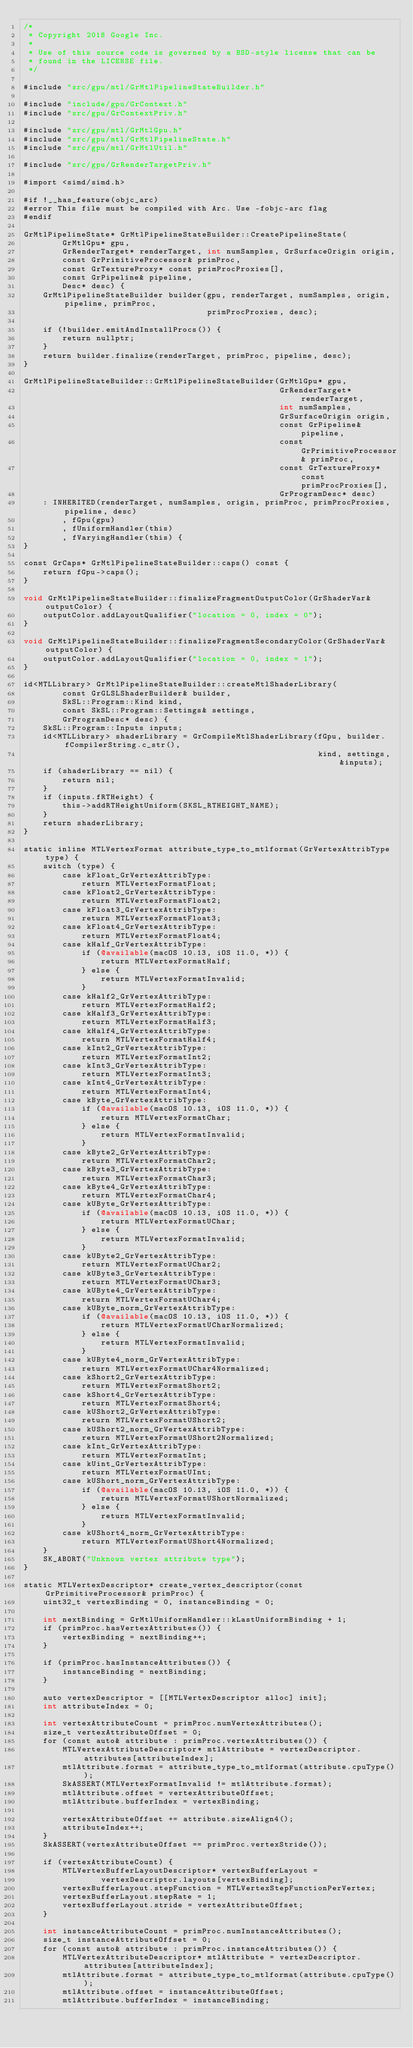Convert code to text. <code><loc_0><loc_0><loc_500><loc_500><_ObjectiveC_>/*
 * Copyright 2018 Google Inc.
 *
 * Use of this source code is governed by a BSD-style license that can be
 * found in the LICENSE file.
 */

#include "src/gpu/mtl/GrMtlPipelineStateBuilder.h"

#include "include/gpu/GrContext.h"
#include "src/gpu/GrContextPriv.h"

#include "src/gpu/mtl/GrMtlGpu.h"
#include "src/gpu/mtl/GrMtlPipelineState.h"
#include "src/gpu/mtl/GrMtlUtil.h"

#include "src/gpu/GrRenderTargetPriv.h"

#import <simd/simd.h>

#if !__has_feature(objc_arc)
#error This file must be compiled with Arc. Use -fobjc-arc flag
#endif

GrMtlPipelineState* GrMtlPipelineStateBuilder::CreatePipelineState(
        GrMtlGpu* gpu,
        GrRenderTarget* renderTarget, int numSamples, GrSurfaceOrigin origin,
        const GrPrimitiveProcessor& primProc,
        const GrTextureProxy* const primProcProxies[],
        const GrPipeline& pipeline,
        Desc* desc) {
    GrMtlPipelineStateBuilder builder(gpu, renderTarget, numSamples, origin, pipeline, primProc,
                                      primProcProxies, desc);

    if (!builder.emitAndInstallProcs()) {
        return nullptr;
    }
    return builder.finalize(renderTarget, primProc, pipeline, desc);
}

GrMtlPipelineStateBuilder::GrMtlPipelineStateBuilder(GrMtlGpu* gpu,
                                                     GrRenderTarget* renderTarget,
                                                     int numSamples,
                                                     GrSurfaceOrigin origin,
                                                     const GrPipeline& pipeline,
                                                     const GrPrimitiveProcessor& primProc,
                                                     const GrTextureProxy* const primProcProxies[],
                                                     GrProgramDesc* desc)
    : INHERITED(renderTarget, numSamples, origin, primProc, primProcProxies, pipeline, desc)
        , fGpu(gpu)
        , fUniformHandler(this)
        , fVaryingHandler(this) {
}

const GrCaps* GrMtlPipelineStateBuilder::caps() const {
    return fGpu->caps();
}

void GrMtlPipelineStateBuilder::finalizeFragmentOutputColor(GrShaderVar& outputColor) {
    outputColor.addLayoutQualifier("location = 0, index = 0");
}

void GrMtlPipelineStateBuilder::finalizeFragmentSecondaryColor(GrShaderVar& outputColor) {
    outputColor.addLayoutQualifier("location = 0, index = 1");
}

id<MTLLibrary> GrMtlPipelineStateBuilder::createMtlShaderLibrary(
        const GrGLSLShaderBuilder& builder,
        SkSL::Program::Kind kind,
        const SkSL::Program::Settings& settings,
        GrProgramDesc* desc) {
    SkSL::Program::Inputs inputs;
    id<MTLLibrary> shaderLibrary = GrCompileMtlShaderLibrary(fGpu, builder.fCompilerString.c_str(),
                                                             kind, settings, &inputs);
    if (shaderLibrary == nil) {
        return nil;
    }
    if (inputs.fRTHeight) {
        this->addRTHeightUniform(SKSL_RTHEIGHT_NAME);
    }
    return shaderLibrary;
}

static inline MTLVertexFormat attribute_type_to_mtlformat(GrVertexAttribType type) {
    switch (type) {
        case kFloat_GrVertexAttribType:
            return MTLVertexFormatFloat;
        case kFloat2_GrVertexAttribType:
            return MTLVertexFormatFloat2;
        case kFloat3_GrVertexAttribType:
            return MTLVertexFormatFloat3;
        case kFloat4_GrVertexAttribType:
            return MTLVertexFormatFloat4;
        case kHalf_GrVertexAttribType:
            if (@available(macOS 10.13, iOS 11.0, *)) {
                return MTLVertexFormatHalf;
            } else {
                return MTLVertexFormatInvalid;
            }
        case kHalf2_GrVertexAttribType:
            return MTLVertexFormatHalf2;
        case kHalf3_GrVertexAttribType:
            return MTLVertexFormatHalf3;
        case kHalf4_GrVertexAttribType:
            return MTLVertexFormatHalf4;
        case kInt2_GrVertexAttribType:
            return MTLVertexFormatInt2;
        case kInt3_GrVertexAttribType:
            return MTLVertexFormatInt3;
        case kInt4_GrVertexAttribType:
            return MTLVertexFormatInt4;
        case kByte_GrVertexAttribType:
            if (@available(macOS 10.13, iOS 11.0, *)) {
                return MTLVertexFormatChar;
            } else {
                return MTLVertexFormatInvalid;
            }
        case kByte2_GrVertexAttribType:
            return MTLVertexFormatChar2;
        case kByte3_GrVertexAttribType:
            return MTLVertexFormatChar3;
        case kByte4_GrVertexAttribType:
            return MTLVertexFormatChar4;
        case kUByte_GrVertexAttribType:
            if (@available(macOS 10.13, iOS 11.0, *)) {
                return MTLVertexFormatUChar;
            } else {
                return MTLVertexFormatInvalid;
            }
        case kUByte2_GrVertexAttribType:
            return MTLVertexFormatUChar2;
        case kUByte3_GrVertexAttribType:
            return MTLVertexFormatUChar3;
        case kUByte4_GrVertexAttribType:
            return MTLVertexFormatUChar4;
        case kUByte_norm_GrVertexAttribType:
            if (@available(macOS 10.13, iOS 11.0, *)) {
                return MTLVertexFormatUCharNormalized;
            } else {
                return MTLVertexFormatInvalid;
            }
        case kUByte4_norm_GrVertexAttribType:
            return MTLVertexFormatUChar4Normalized;
        case kShort2_GrVertexAttribType:
            return MTLVertexFormatShort2;
        case kShort4_GrVertexAttribType:
            return MTLVertexFormatShort4;
        case kUShort2_GrVertexAttribType:
            return MTLVertexFormatUShort2;
        case kUShort2_norm_GrVertexAttribType:
            return MTLVertexFormatUShort2Normalized;
        case kInt_GrVertexAttribType:
            return MTLVertexFormatInt;
        case kUint_GrVertexAttribType:
            return MTLVertexFormatUInt;
        case kUShort_norm_GrVertexAttribType:
            if (@available(macOS 10.13, iOS 11.0, *)) {
                return MTLVertexFormatUShortNormalized;
            } else {
                return MTLVertexFormatInvalid;
            }
        case kUShort4_norm_GrVertexAttribType:
            return MTLVertexFormatUShort4Normalized;
    }
    SK_ABORT("Unknown vertex attribute type");
}

static MTLVertexDescriptor* create_vertex_descriptor(const GrPrimitiveProcessor& primProc) {
    uint32_t vertexBinding = 0, instanceBinding = 0;

    int nextBinding = GrMtlUniformHandler::kLastUniformBinding + 1;
    if (primProc.hasVertexAttributes()) {
        vertexBinding = nextBinding++;
    }

    if (primProc.hasInstanceAttributes()) {
        instanceBinding = nextBinding;
    }

    auto vertexDescriptor = [[MTLVertexDescriptor alloc] init];
    int attributeIndex = 0;

    int vertexAttributeCount = primProc.numVertexAttributes();
    size_t vertexAttributeOffset = 0;
    for (const auto& attribute : primProc.vertexAttributes()) {
        MTLVertexAttributeDescriptor* mtlAttribute = vertexDescriptor.attributes[attributeIndex];
        mtlAttribute.format = attribute_type_to_mtlformat(attribute.cpuType());
        SkASSERT(MTLVertexFormatInvalid != mtlAttribute.format);
        mtlAttribute.offset = vertexAttributeOffset;
        mtlAttribute.bufferIndex = vertexBinding;

        vertexAttributeOffset += attribute.sizeAlign4();
        attributeIndex++;
    }
    SkASSERT(vertexAttributeOffset == primProc.vertexStride());

    if (vertexAttributeCount) {
        MTLVertexBufferLayoutDescriptor* vertexBufferLayout =
                vertexDescriptor.layouts[vertexBinding];
        vertexBufferLayout.stepFunction = MTLVertexStepFunctionPerVertex;
        vertexBufferLayout.stepRate = 1;
        vertexBufferLayout.stride = vertexAttributeOffset;
    }

    int instanceAttributeCount = primProc.numInstanceAttributes();
    size_t instanceAttributeOffset = 0;
    for (const auto& attribute : primProc.instanceAttributes()) {
        MTLVertexAttributeDescriptor* mtlAttribute = vertexDescriptor.attributes[attributeIndex];
        mtlAttribute.format = attribute_type_to_mtlformat(attribute.cpuType());
        mtlAttribute.offset = instanceAttributeOffset;
        mtlAttribute.bufferIndex = instanceBinding;
</code> 